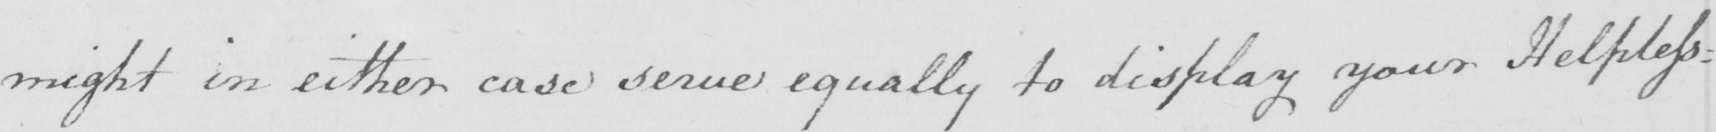Can you tell me what this handwritten text says? might in either case serve equally to display your Helpless : 